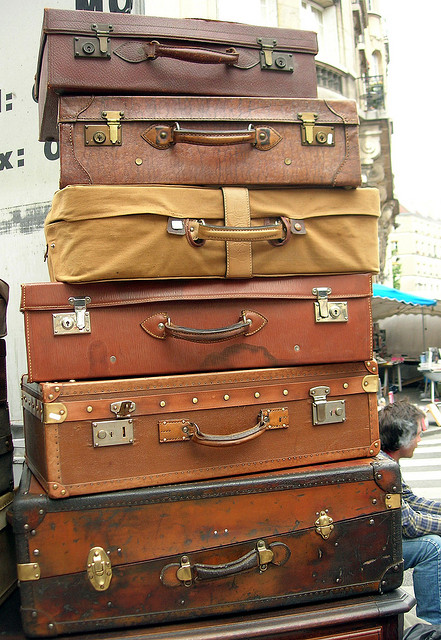What might be the story behind these stacked suitcases? These suitcases could belong to a seasoned traveler or perhaps they're part of a street art installation, symbolizing the journey of life or the baggage we carry through different experiences. Their vintage look suggests a nostalgic connection to travel in past decades. 